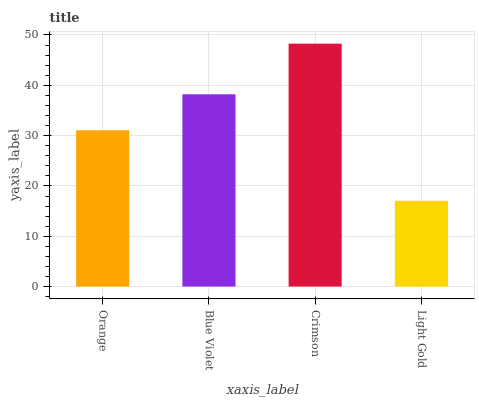Is Light Gold the minimum?
Answer yes or no. Yes. Is Crimson the maximum?
Answer yes or no. Yes. Is Blue Violet the minimum?
Answer yes or no. No. Is Blue Violet the maximum?
Answer yes or no. No. Is Blue Violet greater than Orange?
Answer yes or no. Yes. Is Orange less than Blue Violet?
Answer yes or no. Yes. Is Orange greater than Blue Violet?
Answer yes or no. No. Is Blue Violet less than Orange?
Answer yes or no. No. Is Blue Violet the high median?
Answer yes or no. Yes. Is Orange the low median?
Answer yes or no. Yes. Is Crimson the high median?
Answer yes or no. No. Is Light Gold the low median?
Answer yes or no. No. 